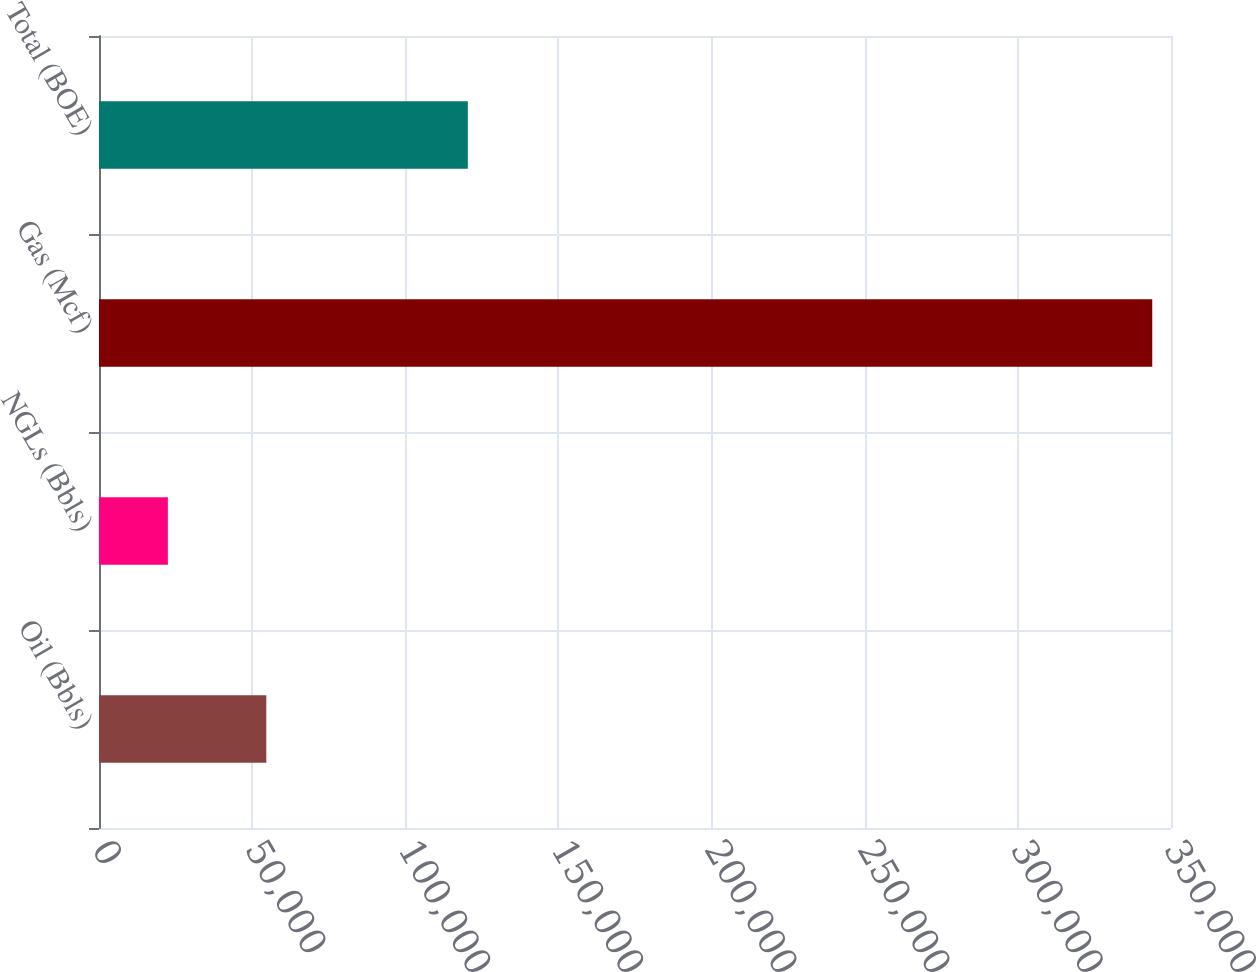<chart> <loc_0><loc_0><loc_500><loc_500><bar_chart><fcel>Oil (Bbls)<fcel>NGLs (Bbls)<fcel>Gas (Mcf)<fcel>Total (BOE)<nl><fcel>54626.2<fcel>22487<fcel>343879<fcel>120418<nl></chart> 